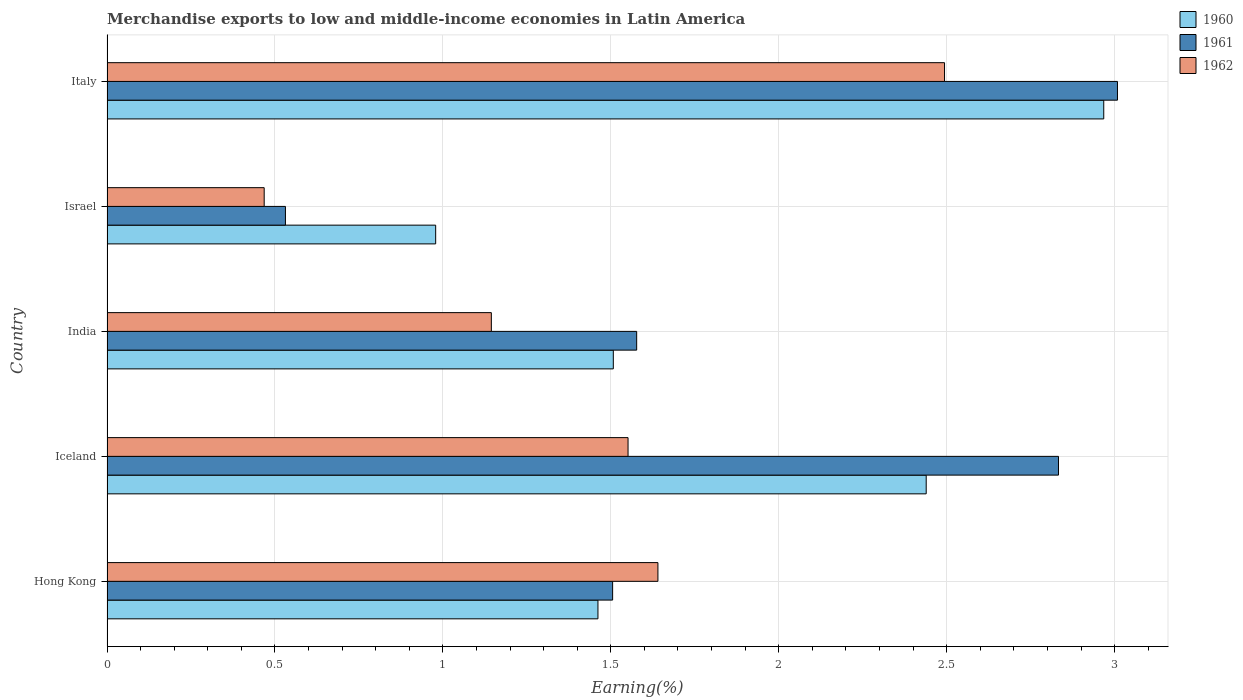How many groups of bars are there?
Offer a very short reply. 5. Are the number of bars per tick equal to the number of legend labels?
Your answer should be compact. Yes. How many bars are there on the 3rd tick from the top?
Offer a very short reply. 3. How many bars are there on the 2nd tick from the bottom?
Provide a succinct answer. 3. What is the percentage of amount earned from merchandise exports in 1960 in Iceland?
Make the answer very short. 2.44. Across all countries, what is the maximum percentage of amount earned from merchandise exports in 1960?
Provide a short and direct response. 2.97. Across all countries, what is the minimum percentage of amount earned from merchandise exports in 1962?
Give a very brief answer. 0.47. In which country was the percentage of amount earned from merchandise exports in 1961 minimum?
Your response must be concise. Israel. What is the total percentage of amount earned from merchandise exports in 1961 in the graph?
Offer a terse response. 9.45. What is the difference between the percentage of amount earned from merchandise exports in 1961 in Hong Kong and that in Italy?
Give a very brief answer. -1.5. What is the difference between the percentage of amount earned from merchandise exports in 1962 in Hong Kong and the percentage of amount earned from merchandise exports in 1961 in Iceland?
Your response must be concise. -1.19. What is the average percentage of amount earned from merchandise exports in 1962 per country?
Keep it short and to the point. 1.46. What is the difference between the percentage of amount earned from merchandise exports in 1960 and percentage of amount earned from merchandise exports in 1961 in Iceland?
Your answer should be very brief. -0.39. What is the ratio of the percentage of amount earned from merchandise exports in 1962 in India to that in Israel?
Give a very brief answer. 2.45. Is the percentage of amount earned from merchandise exports in 1960 in Iceland less than that in India?
Provide a short and direct response. No. What is the difference between the highest and the second highest percentage of amount earned from merchandise exports in 1962?
Offer a terse response. 0.85. What is the difference between the highest and the lowest percentage of amount earned from merchandise exports in 1960?
Provide a succinct answer. 1.99. In how many countries, is the percentage of amount earned from merchandise exports in 1961 greater than the average percentage of amount earned from merchandise exports in 1961 taken over all countries?
Your answer should be very brief. 2. Is the sum of the percentage of amount earned from merchandise exports in 1961 in India and Israel greater than the maximum percentage of amount earned from merchandise exports in 1962 across all countries?
Your response must be concise. No. Are all the bars in the graph horizontal?
Keep it short and to the point. Yes. What is the difference between two consecutive major ticks on the X-axis?
Offer a terse response. 0.5. Are the values on the major ticks of X-axis written in scientific E-notation?
Ensure brevity in your answer.  No. Does the graph contain any zero values?
Your answer should be compact. No. Does the graph contain grids?
Give a very brief answer. Yes. Where does the legend appear in the graph?
Make the answer very short. Top right. How many legend labels are there?
Ensure brevity in your answer.  3. How are the legend labels stacked?
Make the answer very short. Vertical. What is the title of the graph?
Offer a terse response. Merchandise exports to low and middle-income economies in Latin America. What is the label or title of the X-axis?
Your answer should be compact. Earning(%). What is the label or title of the Y-axis?
Provide a short and direct response. Country. What is the Earning(%) of 1960 in Hong Kong?
Offer a very short reply. 1.46. What is the Earning(%) of 1961 in Hong Kong?
Offer a very short reply. 1.51. What is the Earning(%) of 1962 in Hong Kong?
Your answer should be compact. 1.64. What is the Earning(%) in 1960 in Iceland?
Your response must be concise. 2.44. What is the Earning(%) in 1961 in Iceland?
Provide a succinct answer. 2.83. What is the Earning(%) in 1962 in Iceland?
Keep it short and to the point. 1.55. What is the Earning(%) of 1960 in India?
Offer a very short reply. 1.51. What is the Earning(%) of 1961 in India?
Ensure brevity in your answer.  1.58. What is the Earning(%) of 1962 in India?
Offer a terse response. 1.14. What is the Earning(%) of 1960 in Israel?
Your response must be concise. 0.98. What is the Earning(%) of 1961 in Israel?
Provide a short and direct response. 0.53. What is the Earning(%) of 1962 in Israel?
Make the answer very short. 0.47. What is the Earning(%) in 1960 in Italy?
Offer a very short reply. 2.97. What is the Earning(%) of 1961 in Italy?
Give a very brief answer. 3.01. What is the Earning(%) in 1962 in Italy?
Ensure brevity in your answer.  2.49. Across all countries, what is the maximum Earning(%) of 1960?
Your response must be concise. 2.97. Across all countries, what is the maximum Earning(%) in 1961?
Keep it short and to the point. 3.01. Across all countries, what is the maximum Earning(%) in 1962?
Your answer should be compact. 2.49. Across all countries, what is the minimum Earning(%) of 1960?
Offer a very short reply. 0.98. Across all countries, what is the minimum Earning(%) of 1961?
Your response must be concise. 0.53. Across all countries, what is the minimum Earning(%) in 1962?
Keep it short and to the point. 0.47. What is the total Earning(%) of 1960 in the graph?
Offer a very short reply. 9.35. What is the total Earning(%) in 1961 in the graph?
Make the answer very short. 9.45. What is the total Earning(%) in 1962 in the graph?
Your response must be concise. 7.3. What is the difference between the Earning(%) in 1960 in Hong Kong and that in Iceland?
Give a very brief answer. -0.98. What is the difference between the Earning(%) of 1961 in Hong Kong and that in Iceland?
Your answer should be compact. -1.33. What is the difference between the Earning(%) in 1962 in Hong Kong and that in Iceland?
Ensure brevity in your answer.  0.09. What is the difference between the Earning(%) in 1960 in Hong Kong and that in India?
Your answer should be very brief. -0.05. What is the difference between the Earning(%) of 1961 in Hong Kong and that in India?
Make the answer very short. -0.07. What is the difference between the Earning(%) in 1962 in Hong Kong and that in India?
Make the answer very short. 0.5. What is the difference between the Earning(%) of 1960 in Hong Kong and that in Israel?
Keep it short and to the point. 0.48. What is the difference between the Earning(%) of 1961 in Hong Kong and that in Israel?
Offer a terse response. 0.97. What is the difference between the Earning(%) in 1962 in Hong Kong and that in Israel?
Offer a very short reply. 1.17. What is the difference between the Earning(%) in 1960 in Hong Kong and that in Italy?
Your answer should be very brief. -1.51. What is the difference between the Earning(%) in 1961 in Hong Kong and that in Italy?
Offer a very short reply. -1.5. What is the difference between the Earning(%) in 1962 in Hong Kong and that in Italy?
Keep it short and to the point. -0.85. What is the difference between the Earning(%) in 1960 in Iceland and that in India?
Your answer should be very brief. 0.93. What is the difference between the Earning(%) of 1961 in Iceland and that in India?
Provide a succinct answer. 1.26. What is the difference between the Earning(%) in 1962 in Iceland and that in India?
Offer a very short reply. 0.41. What is the difference between the Earning(%) in 1960 in Iceland and that in Israel?
Your answer should be compact. 1.46. What is the difference between the Earning(%) in 1961 in Iceland and that in Israel?
Give a very brief answer. 2.3. What is the difference between the Earning(%) in 1962 in Iceland and that in Israel?
Provide a succinct answer. 1.08. What is the difference between the Earning(%) in 1960 in Iceland and that in Italy?
Provide a short and direct response. -0.53. What is the difference between the Earning(%) in 1961 in Iceland and that in Italy?
Ensure brevity in your answer.  -0.18. What is the difference between the Earning(%) in 1962 in Iceland and that in Italy?
Make the answer very short. -0.94. What is the difference between the Earning(%) of 1960 in India and that in Israel?
Provide a succinct answer. 0.53. What is the difference between the Earning(%) of 1961 in India and that in Israel?
Keep it short and to the point. 1.05. What is the difference between the Earning(%) of 1962 in India and that in Israel?
Give a very brief answer. 0.68. What is the difference between the Earning(%) in 1960 in India and that in Italy?
Your response must be concise. -1.46. What is the difference between the Earning(%) in 1961 in India and that in Italy?
Your answer should be compact. -1.43. What is the difference between the Earning(%) of 1962 in India and that in Italy?
Offer a terse response. -1.35. What is the difference between the Earning(%) in 1960 in Israel and that in Italy?
Provide a succinct answer. -1.99. What is the difference between the Earning(%) in 1961 in Israel and that in Italy?
Offer a very short reply. -2.48. What is the difference between the Earning(%) of 1962 in Israel and that in Italy?
Ensure brevity in your answer.  -2.03. What is the difference between the Earning(%) of 1960 in Hong Kong and the Earning(%) of 1961 in Iceland?
Ensure brevity in your answer.  -1.37. What is the difference between the Earning(%) of 1960 in Hong Kong and the Earning(%) of 1962 in Iceland?
Make the answer very short. -0.09. What is the difference between the Earning(%) of 1961 in Hong Kong and the Earning(%) of 1962 in Iceland?
Your answer should be compact. -0.05. What is the difference between the Earning(%) in 1960 in Hong Kong and the Earning(%) in 1961 in India?
Give a very brief answer. -0.12. What is the difference between the Earning(%) of 1960 in Hong Kong and the Earning(%) of 1962 in India?
Offer a very short reply. 0.32. What is the difference between the Earning(%) in 1961 in Hong Kong and the Earning(%) in 1962 in India?
Your answer should be very brief. 0.36. What is the difference between the Earning(%) of 1960 in Hong Kong and the Earning(%) of 1961 in Israel?
Your response must be concise. 0.93. What is the difference between the Earning(%) of 1960 in Hong Kong and the Earning(%) of 1962 in Israel?
Offer a terse response. 0.99. What is the difference between the Earning(%) in 1961 in Hong Kong and the Earning(%) in 1962 in Israel?
Your response must be concise. 1.04. What is the difference between the Earning(%) in 1960 in Hong Kong and the Earning(%) in 1961 in Italy?
Give a very brief answer. -1.55. What is the difference between the Earning(%) in 1960 in Hong Kong and the Earning(%) in 1962 in Italy?
Offer a terse response. -1.03. What is the difference between the Earning(%) in 1961 in Hong Kong and the Earning(%) in 1962 in Italy?
Keep it short and to the point. -0.99. What is the difference between the Earning(%) of 1960 in Iceland and the Earning(%) of 1961 in India?
Your answer should be compact. 0.86. What is the difference between the Earning(%) in 1960 in Iceland and the Earning(%) in 1962 in India?
Provide a succinct answer. 1.29. What is the difference between the Earning(%) in 1961 in Iceland and the Earning(%) in 1962 in India?
Your answer should be very brief. 1.69. What is the difference between the Earning(%) in 1960 in Iceland and the Earning(%) in 1961 in Israel?
Provide a succinct answer. 1.91. What is the difference between the Earning(%) in 1960 in Iceland and the Earning(%) in 1962 in Israel?
Ensure brevity in your answer.  1.97. What is the difference between the Earning(%) of 1961 in Iceland and the Earning(%) of 1962 in Israel?
Give a very brief answer. 2.36. What is the difference between the Earning(%) of 1960 in Iceland and the Earning(%) of 1961 in Italy?
Offer a very short reply. -0.57. What is the difference between the Earning(%) in 1960 in Iceland and the Earning(%) in 1962 in Italy?
Give a very brief answer. -0.05. What is the difference between the Earning(%) in 1961 in Iceland and the Earning(%) in 1962 in Italy?
Provide a succinct answer. 0.34. What is the difference between the Earning(%) in 1960 in India and the Earning(%) in 1961 in Israel?
Offer a terse response. 0.98. What is the difference between the Earning(%) in 1960 in India and the Earning(%) in 1962 in Israel?
Keep it short and to the point. 1.04. What is the difference between the Earning(%) of 1961 in India and the Earning(%) of 1962 in Israel?
Offer a terse response. 1.11. What is the difference between the Earning(%) in 1960 in India and the Earning(%) in 1961 in Italy?
Keep it short and to the point. -1.5. What is the difference between the Earning(%) in 1960 in India and the Earning(%) in 1962 in Italy?
Provide a succinct answer. -0.99. What is the difference between the Earning(%) in 1961 in India and the Earning(%) in 1962 in Italy?
Your response must be concise. -0.92. What is the difference between the Earning(%) in 1960 in Israel and the Earning(%) in 1961 in Italy?
Make the answer very short. -2.03. What is the difference between the Earning(%) in 1960 in Israel and the Earning(%) in 1962 in Italy?
Ensure brevity in your answer.  -1.51. What is the difference between the Earning(%) of 1961 in Israel and the Earning(%) of 1962 in Italy?
Your answer should be compact. -1.96. What is the average Earning(%) in 1960 per country?
Keep it short and to the point. 1.87. What is the average Earning(%) of 1961 per country?
Your response must be concise. 1.89. What is the average Earning(%) in 1962 per country?
Offer a terse response. 1.46. What is the difference between the Earning(%) of 1960 and Earning(%) of 1961 in Hong Kong?
Offer a terse response. -0.04. What is the difference between the Earning(%) in 1960 and Earning(%) in 1962 in Hong Kong?
Keep it short and to the point. -0.18. What is the difference between the Earning(%) of 1961 and Earning(%) of 1962 in Hong Kong?
Your answer should be very brief. -0.13. What is the difference between the Earning(%) in 1960 and Earning(%) in 1961 in Iceland?
Your response must be concise. -0.39. What is the difference between the Earning(%) of 1960 and Earning(%) of 1962 in Iceland?
Your response must be concise. 0.89. What is the difference between the Earning(%) in 1961 and Earning(%) in 1962 in Iceland?
Offer a very short reply. 1.28. What is the difference between the Earning(%) of 1960 and Earning(%) of 1961 in India?
Provide a succinct answer. -0.07. What is the difference between the Earning(%) in 1960 and Earning(%) in 1962 in India?
Your answer should be very brief. 0.36. What is the difference between the Earning(%) of 1961 and Earning(%) of 1962 in India?
Ensure brevity in your answer.  0.43. What is the difference between the Earning(%) of 1960 and Earning(%) of 1961 in Israel?
Offer a terse response. 0.45. What is the difference between the Earning(%) in 1960 and Earning(%) in 1962 in Israel?
Make the answer very short. 0.51. What is the difference between the Earning(%) in 1961 and Earning(%) in 1962 in Israel?
Offer a very short reply. 0.06. What is the difference between the Earning(%) in 1960 and Earning(%) in 1961 in Italy?
Make the answer very short. -0.04. What is the difference between the Earning(%) of 1960 and Earning(%) of 1962 in Italy?
Your answer should be compact. 0.47. What is the difference between the Earning(%) in 1961 and Earning(%) in 1962 in Italy?
Keep it short and to the point. 0.51. What is the ratio of the Earning(%) in 1960 in Hong Kong to that in Iceland?
Make the answer very short. 0.6. What is the ratio of the Earning(%) of 1961 in Hong Kong to that in Iceland?
Your answer should be compact. 0.53. What is the ratio of the Earning(%) of 1962 in Hong Kong to that in Iceland?
Provide a succinct answer. 1.06. What is the ratio of the Earning(%) of 1960 in Hong Kong to that in India?
Ensure brevity in your answer.  0.97. What is the ratio of the Earning(%) in 1961 in Hong Kong to that in India?
Offer a terse response. 0.95. What is the ratio of the Earning(%) of 1962 in Hong Kong to that in India?
Your answer should be very brief. 1.43. What is the ratio of the Earning(%) in 1960 in Hong Kong to that in Israel?
Provide a succinct answer. 1.49. What is the ratio of the Earning(%) of 1961 in Hong Kong to that in Israel?
Give a very brief answer. 2.83. What is the ratio of the Earning(%) of 1962 in Hong Kong to that in Israel?
Give a very brief answer. 3.51. What is the ratio of the Earning(%) of 1960 in Hong Kong to that in Italy?
Provide a short and direct response. 0.49. What is the ratio of the Earning(%) of 1961 in Hong Kong to that in Italy?
Provide a succinct answer. 0.5. What is the ratio of the Earning(%) of 1962 in Hong Kong to that in Italy?
Ensure brevity in your answer.  0.66. What is the ratio of the Earning(%) in 1960 in Iceland to that in India?
Offer a very short reply. 1.62. What is the ratio of the Earning(%) in 1961 in Iceland to that in India?
Your answer should be compact. 1.8. What is the ratio of the Earning(%) of 1962 in Iceland to that in India?
Offer a terse response. 1.36. What is the ratio of the Earning(%) in 1960 in Iceland to that in Israel?
Give a very brief answer. 2.49. What is the ratio of the Earning(%) in 1961 in Iceland to that in Israel?
Give a very brief answer. 5.33. What is the ratio of the Earning(%) of 1962 in Iceland to that in Israel?
Your response must be concise. 3.31. What is the ratio of the Earning(%) in 1960 in Iceland to that in Italy?
Provide a short and direct response. 0.82. What is the ratio of the Earning(%) of 1961 in Iceland to that in Italy?
Your response must be concise. 0.94. What is the ratio of the Earning(%) of 1962 in Iceland to that in Italy?
Offer a terse response. 0.62. What is the ratio of the Earning(%) in 1960 in India to that in Israel?
Make the answer very short. 1.54. What is the ratio of the Earning(%) of 1961 in India to that in Israel?
Your answer should be very brief. 2.97. What is the ratio of the Earning(%) in 1962 in India to that in Israel?
Provide a short and direct response. 2.45. What is the ratio of the Earning(%) of 1960 in India to that in Italy?
Your answer should be compact. 0.51. What is the ratio of the Earning(%) of 1961 in India to that in Italy?
Provide a succinct answer. 0.52. What is the ratio of the Earning(%) of 1962 in India to that in Italy?
Ensure brevity in your answer.  0.46. What is the ratio of the Earning(%) in 1960 in Israel to that in Italy?
Give a very brief answer. 0.33. What is the ratio of the Earning(%) of 1961 in Israel to that in Italy?
Give a very brief answer. 0.18. What is the ratio of the Earning(%) in 1962 in Israel to that in Italy?
Your response must be concise. 0.19. What is the difference between the highest and the second highest Earning(%) of 1960?
Your answer should be very brief. 0.53. What is the difference between the highest and the second highest Earning(%) of 1961?
Your answer should be compact. 0.18. What is the difference between the highest and the second highest Earning(%) in 1962?
Offer a terse response. 0.85. What is the difference between the highest and the lowest Earning(%) of 1960?
Offer a very short reply. 1.99. What is the difference between the highest and the lowest Earning(%) of 1961?
Your response must be concise. 2.48. What is the difference between the highest and the lowest Earning(%) of 1962?
Ensure brevity in your answer.  2.03. 